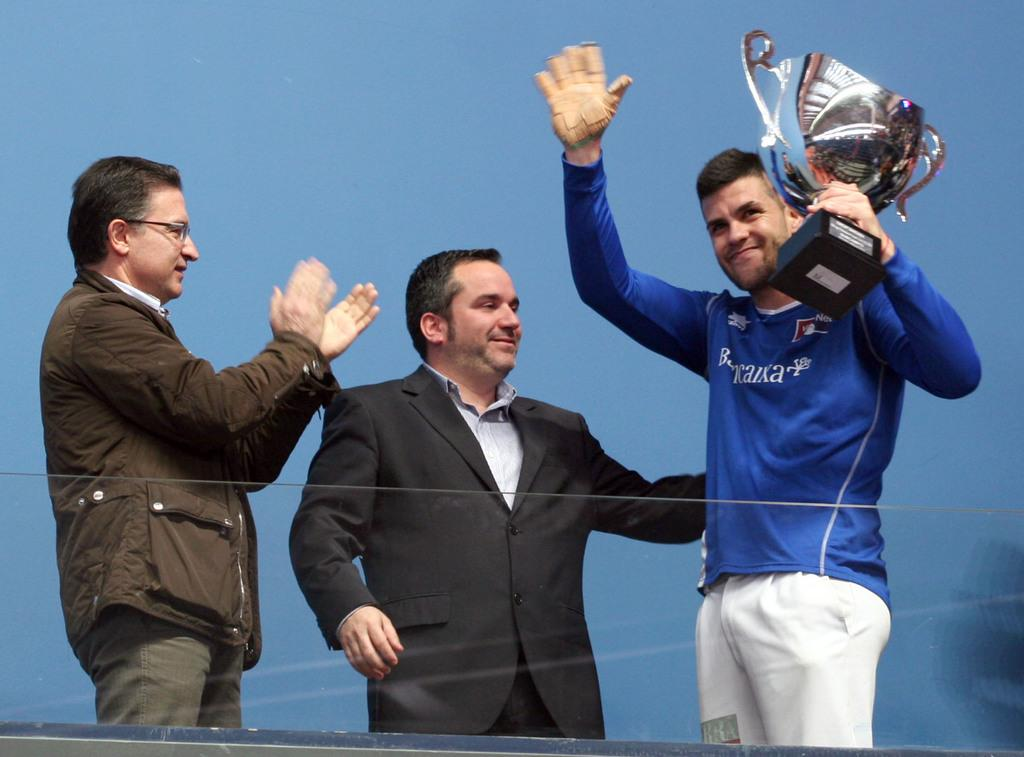How many people are in the image? There are three people in the image. What can be observed about the clothing of the people in the image? The people are wearing different color dresses. What is one person holding in the image? One person is holding a trophy. What is the color of the background in the image? The background in the image is blue. What type of straw is being used to attack the people in the image? There is no straw or any form of attack present in the image. 